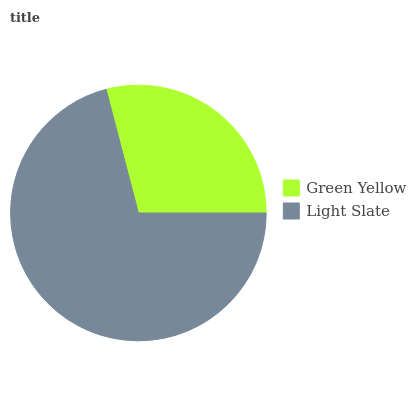Is Green Yellow the minimum?
Answer yes or no. Yes. Is Light Slate the maximum?
Answer yes or no. Yes. Is Light Slate the minimum?
Answer yes or no. No. Is Light Slate greater than Green Yellow?
Answer yes or no. Yes. Is Green Yellow less than Light Slate?
Answer yes or no. Yes. Is Green Yellow greater than Light Slate?
Answer yes or no. No. Is Light Slate less than Green Yellow?
Answer yes or no. No. Is Light Slate the high median?
Answer yes or no. Yes. Is Green Yellow the low median?
Answer yes or no. Yes. Is Green Yellow the high median?
Answer yes or no. No. Is Light Slate the low median?
Answer yes or no. No. 